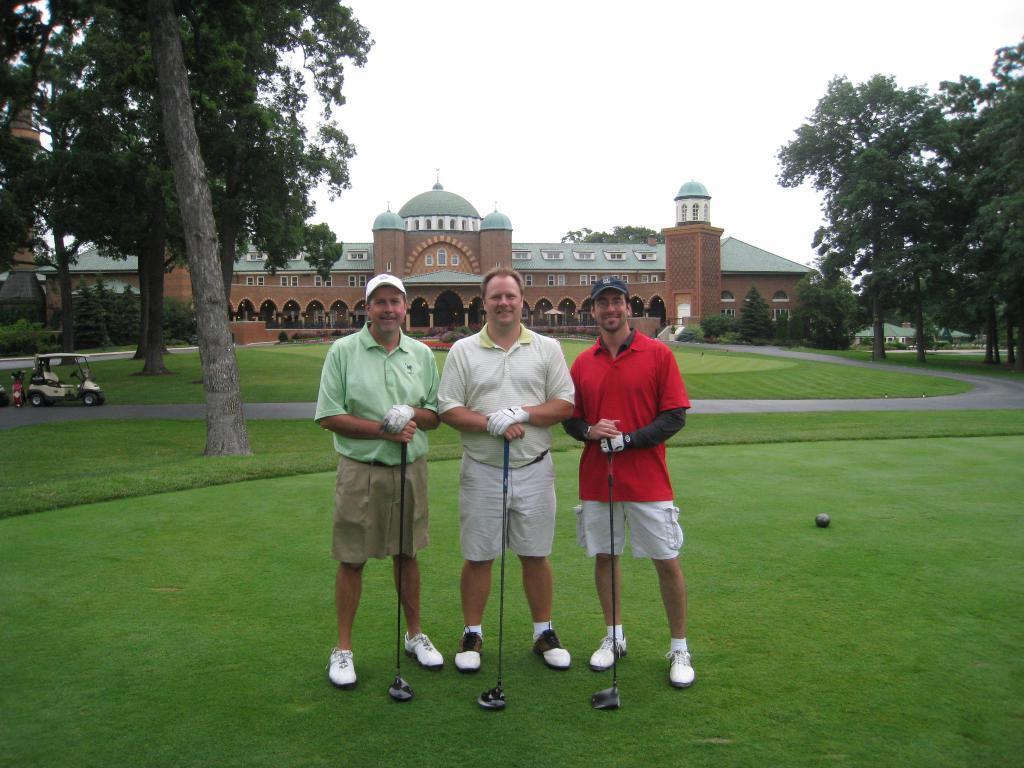Could you give a brief overview of what you see in this image? As we can see in the image there are trees, buildings, windows and in the front there are three persons standing. On the left side there is cart. There is grass and at the top there is sky. The man standing on the left side is wearing green color t shirt. The man standing on the right side is wearing blue color t shirt and the man standing in the middle is wearing white color t shirt. 